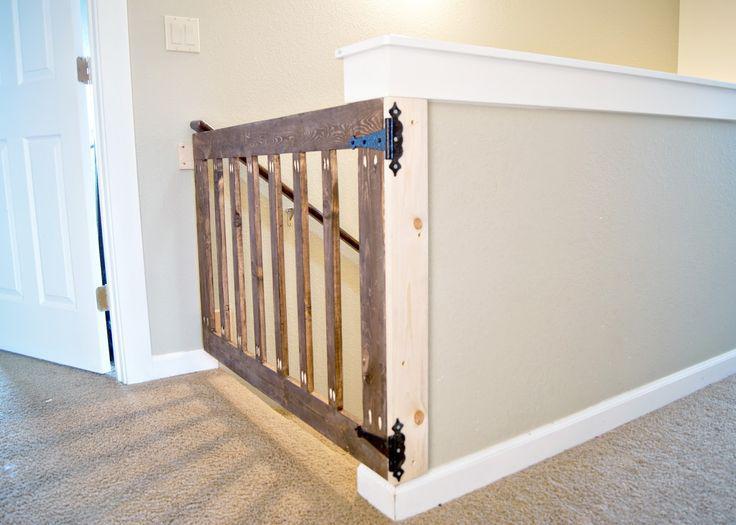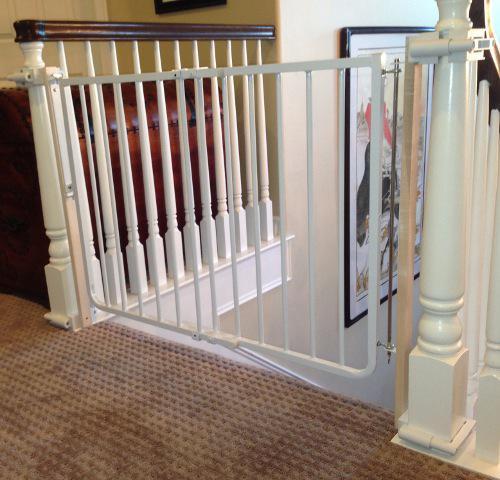The first image is the image on the left, the second image is the image on the right. Examine the images to the left and right. Is the description "Some of the floors upstairs are not carpeted." accurate? Answer yes or no. No. The first image is the image on the left, the second image is the image on the right. Considering the images on both sides, is "The stairway posts are all dark wood." valid? Answer yes or no. No. 